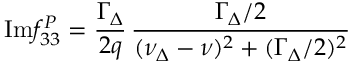Convert formula to latex. <formula><loc_0><loc_0><loc_500><loc_500>I m f _ { 3 3 } ^ { P } = \frac { \Gamma _ { \Delta } } { 2 q } \, \frac { \Gamma _ { \Delta } / 2 } { ( \nu _ { \Delta } - \nu ) ^ { 2 } + ( \Gamma _ { \Delta } / 2 ) ^ { 2 } }</formula> 